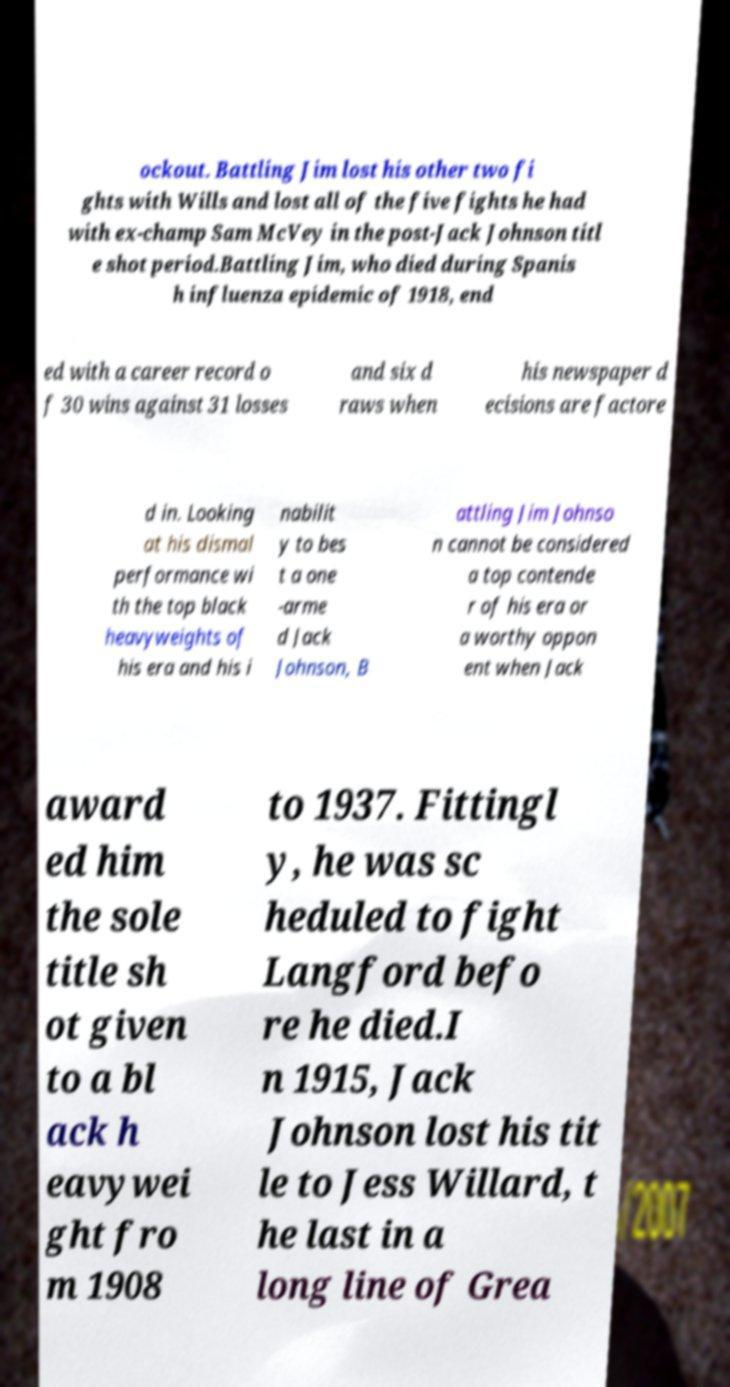For documentation purposes, I need the text within this image transcribed. Could you provide that? ockout. Battling Jim lost his other two fi ghts with Wills and lost all of the five fights he had with ex-champ Sam McVey in the post-Jack Johnson titl e shot period.Battling Jim, who died during Spanis h influenza epidemic of 1918, end ed with a career record o f 30 wins against 31 losses and six d raws when his newspaper d ecisions are factore d in. Looking at his dismal performance wi th the top black heavyweights of his era and his i nabilit y to bes t a one -arme d Jack Johnson, B attling Jim Johnso n cannot be considered a top contende r of his era or a worthy oppon ent when Jack award ed him the sole title sh ot given to a bl ack h eavywei ght fro m 1908 to 1937. Fittingl y, he was sc heduled to fight Langford befo re he died.I n 1915, Jack Johnson lost his tit le to Jess Willard, t he last in a long line of Grea 